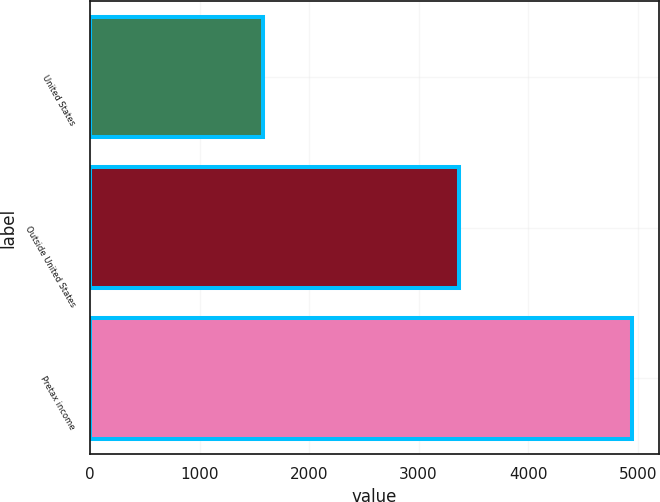Convert chart to OTSL. <chart><loc_0><loc_0><loc_500><loc_500><bar_chart><fcel>United States<fcel>Outside United States<fcel>Pretax income<nl><fcel>1582<fcel>3366<fcel>4948<nl></chart> 